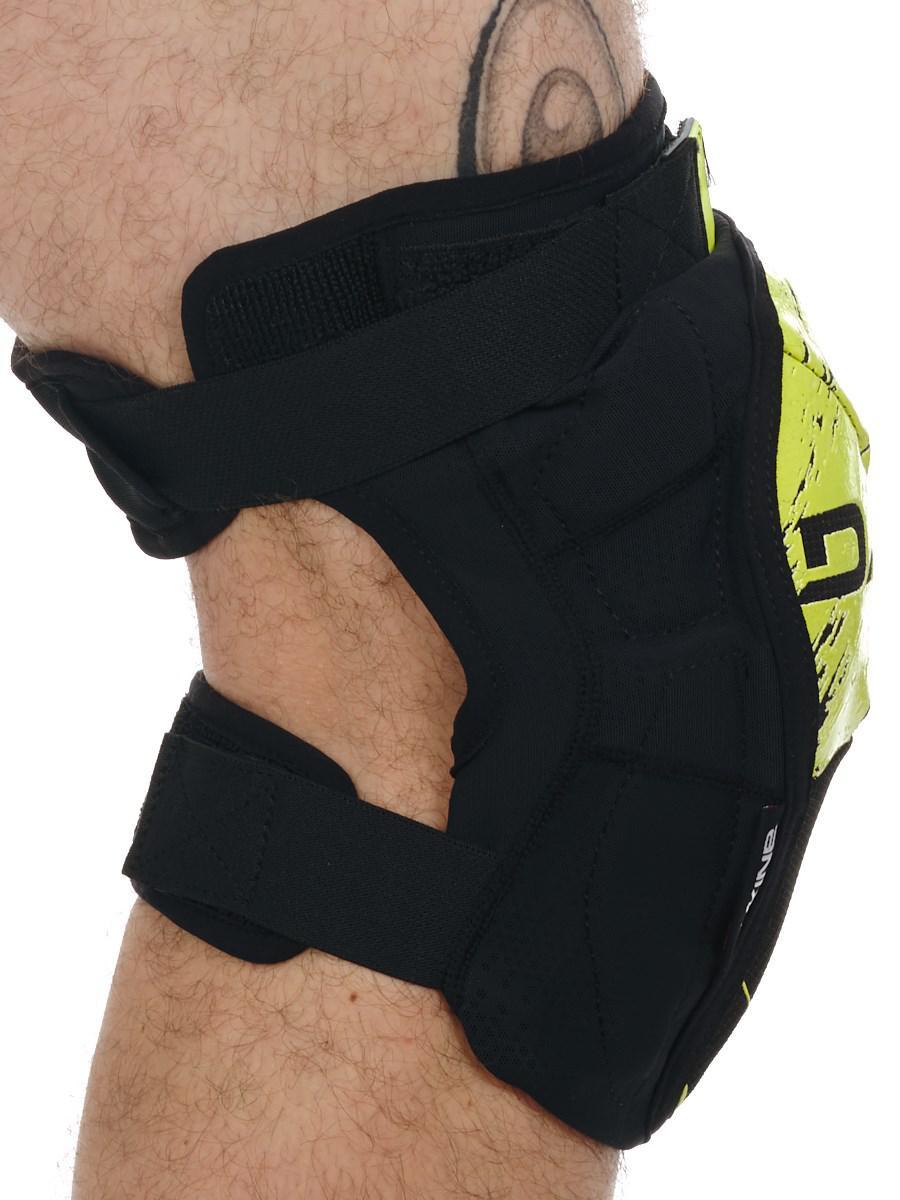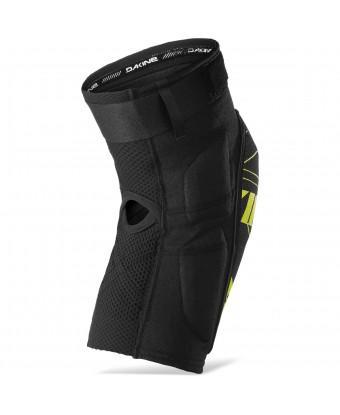The first image is the image on the left, the second image is the image on the right. Assess this claim about the two images: "Both pads are facing in the same direction.". Correct or not? Answer yes or no. Yes. 